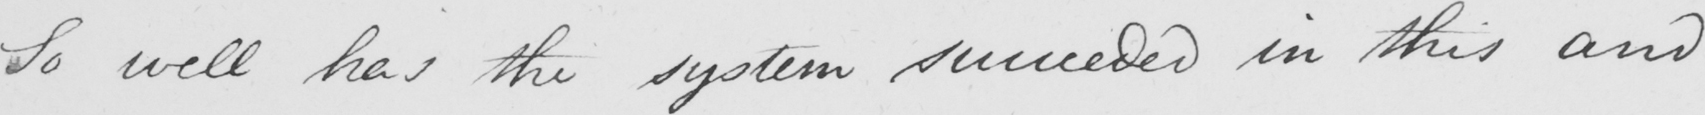Can you read and transcribe this handwriting? So well has the system succeeded in this and 